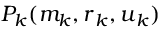<formula> <loc_0><loc_0><loc_500><loc_500>P _ { k } ( m _ { k } , r _ { k } , u _ { k } )</formula> 